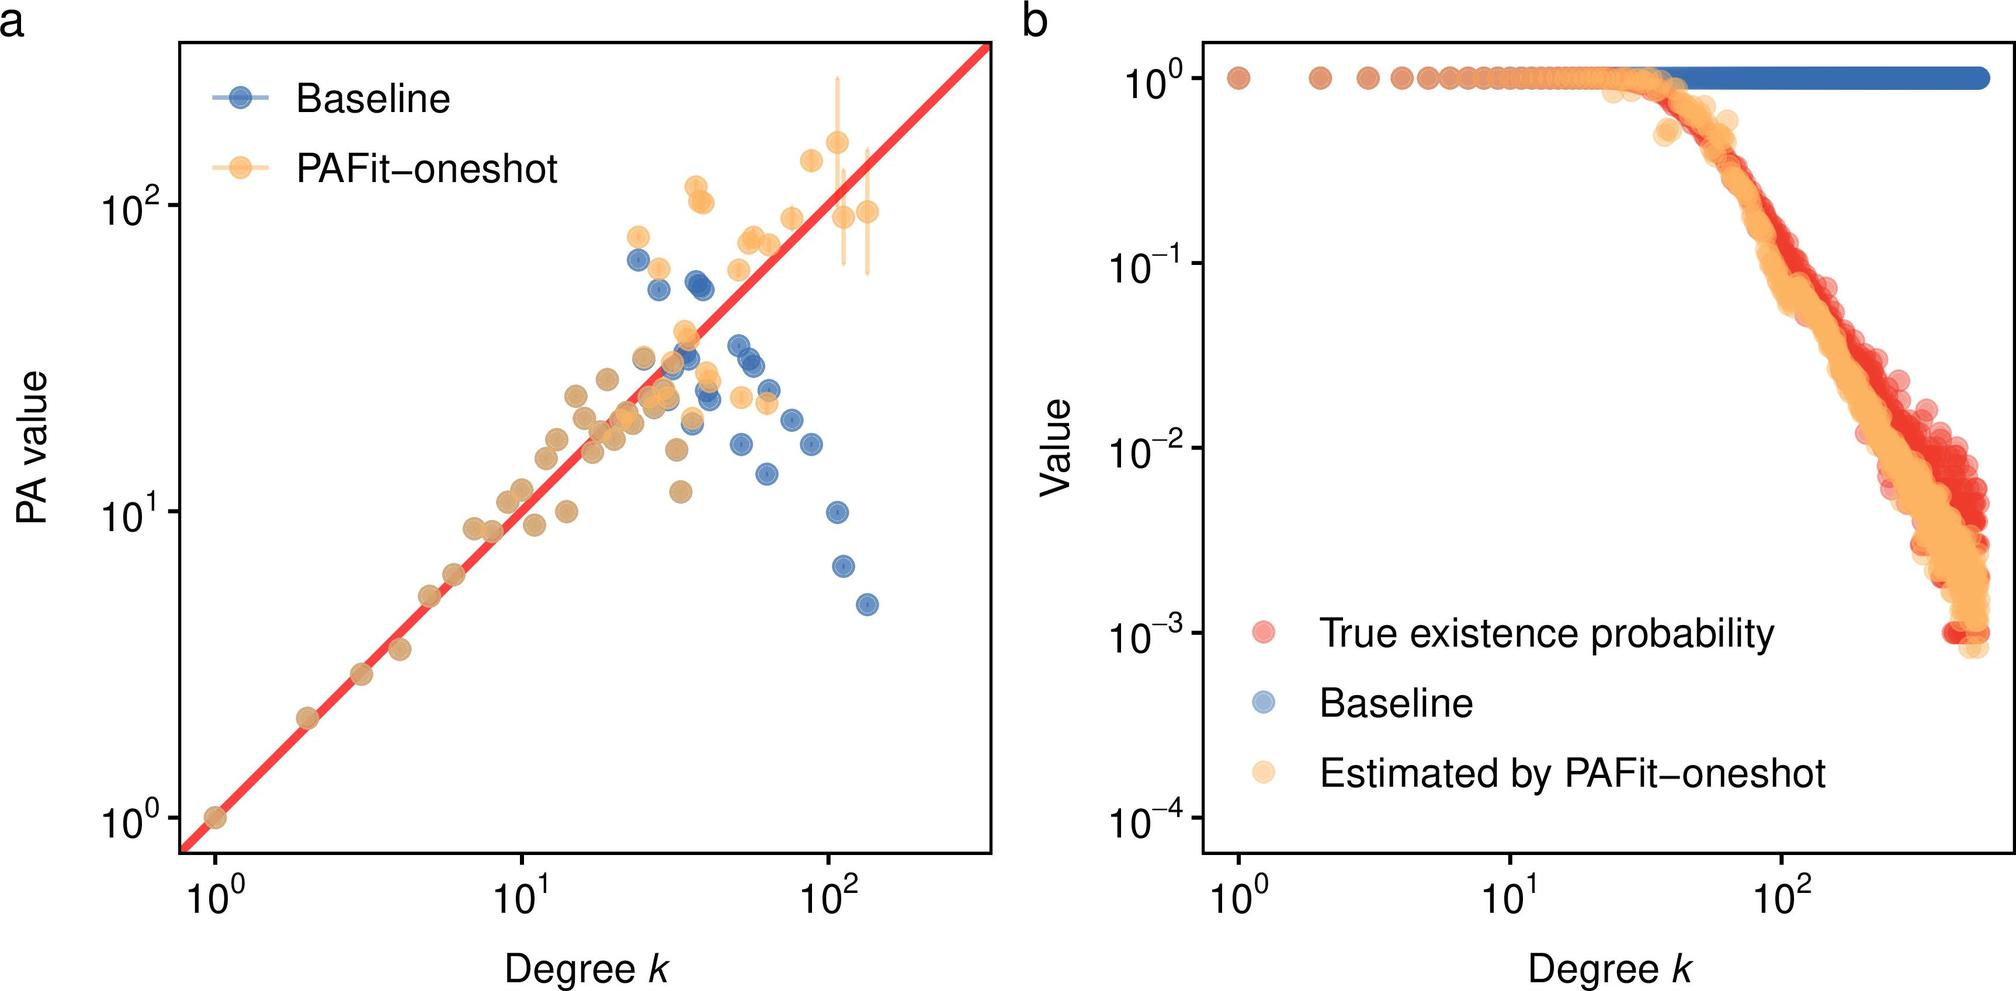Based on figure b, what does the color gradient represent in the context of true existence probability and estimates by PAFit-oneshot? In figure b, the color gradient from blue to red effectively highlights the varying density of data points along the graph, which tracks the true existence probability and estimates by PAFit-oneshot. Darker shades signify areas with higher data concentration, providing visual emphasis on regions of greater or lesser density. This gradient not only supports visual discrimination between different levels of data density but also showcases the distribution pattern of estimated versus true values, helping to interpret the reliability and spread of the estimates made by PAFit-oneshot. 